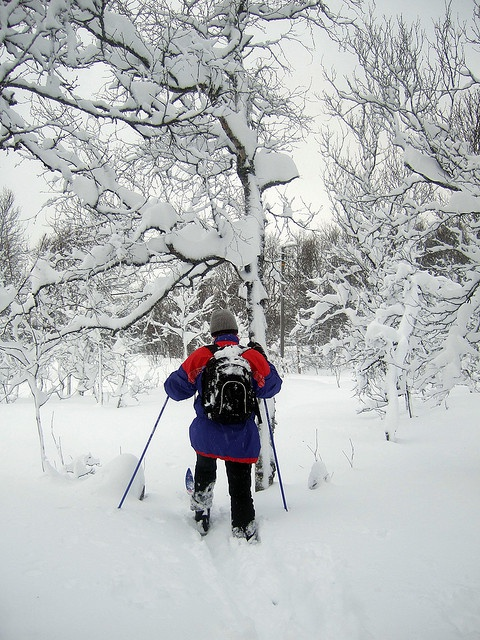Describe the objects in this image and their specific colors. I can see backpack in gray, black, darkgray, and lightgray tones and skis in gray, lightgray, and darkgray tones in this image. 